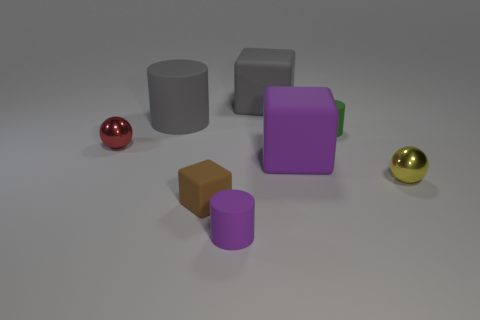How many matte cylinders are to the left of the tiny purple matte cylinder and in front of the green rubber thing?
Your answer should be compact. 0. There is a brown thing that is the same size as the purple cylinder; what is it made of?
Keep it short and to the point. Rubber. Do the ball on the left side of the tiny green matte cylinder and the gray rubber object that is to the left of the brown cube have the same size?
Make the answer very short. No. There is a small purple object; are there any large gray matte blocks in front of it?
Provide a short and direct response. No. The shiny object to the left of the cylinder that is on the right side of the large purple object is what color?
Provide a short and direct response. Red. Are there fewer small balls than green rubber objects?
Your answer should be very brief. No. What number of gray matte things have the same shape as the small brown matte object?
Provide a short and direct response. 1. There is a metal ball that is the same size as the yellow thing; what is its color?
Ensure brevity in your answer.  Red. Are there the same number of big rubber blocks left of the large gray block and big gray cubes in front of the yellow shiny ball?
Make the answer very short. Yes. Is there a gray matte block of the same size as the brown matte thing?
Make the answer very short. No. 